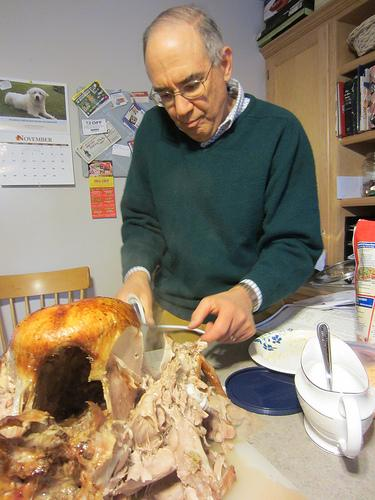What animal is depicted in the calendar and picture? A white colored dog is depicted in both the calendar and the picture. Describe the color and pattern of the saucer on the table. The saucer is blue and white colored, presumably with a floral pattern. Provide a detailed description of the man's appearance. The man has bushy eyebrows, glasses on his face, and wears a green sweater. He is balding with grey hair and has a watch on his hand. What is the man in the image doing? The man is looking at a partially eaten turkey on the table. What type of furniture is in the background and describe its appearance? There is a tall brown cabinet in the background with width 70 and height 70. Describe what the man is holding in his hand while looking at the turkey. The man is holding a carving knife in his hand while looking at the partially carved turkey. What are the characteristics of the object on the top shelf? There is a wicker basket on the top shelf with dimensions of width 28 and height 28. Describe the scene unfolding in this image. A balding grey-haired man wearing glasses is looking at a partially carved turkey on the table, while surrounded by various objects such as a wooden chair, a white gravy boat, and postcards on a board. Identify the key objects and their attributes in this image. Man wearing glasses, carved turkey, plastic blue lid, blue-and-white saucer, brown wooden chair, white dog, postcards on board, watch on man's hand, carving knife, large cut turkey on platter, and gravy bowl with silver utensil. How many postcards can you see on the board, and where are they positioned? There are 10 postcards on the board, positioned at various coordinates with different heights and widths. 